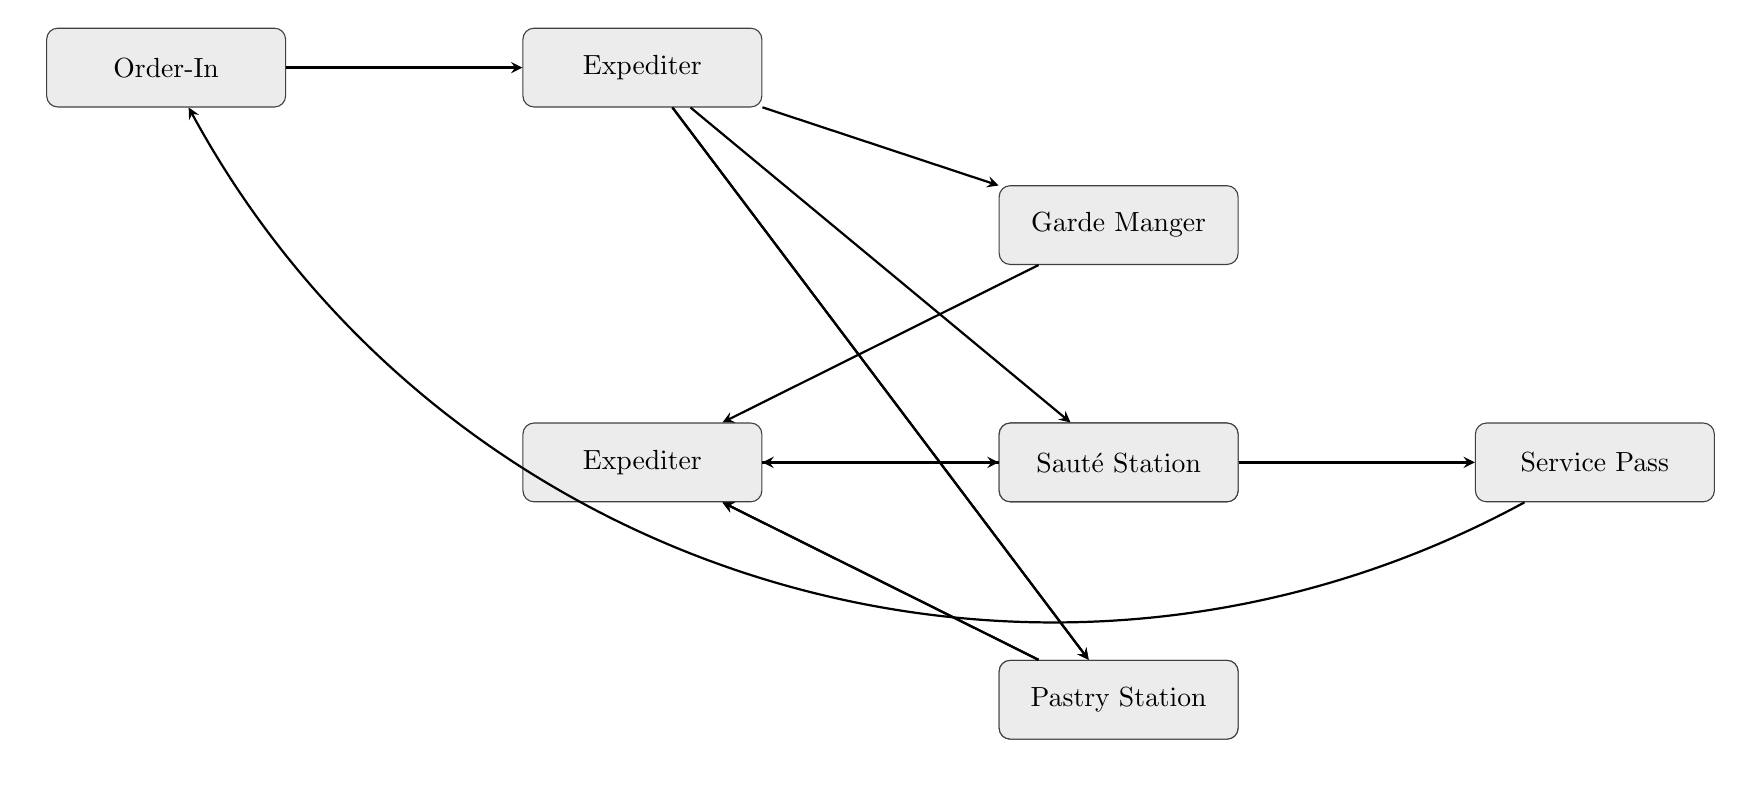What's the first node in the flow? The flow starts with the "Order-In" node where customer orders are received and entered into the system. This is the first step in the communication flow.
Answer: Order-In How many stations communicate with the Expediter? There are four stations that communicate with the Expediter: Garde Manger, Sauté Station, Grill Station, and Pastry Station. This can be counted directly from the arrows leading to the Expediter node.
Answer: Four What does the Garde Manger station prepare? The Garde Manger station prepares cold dishes like salads and appetizers, which is its primary responsibility outlined in the diagram's description of the node.
Answer: Cold dishes Which node follows the Plating node? After the Plating node, the next node is the Service Pass. This is depicted with an arrow leading from Plating to Service Pass in the diagram.
Answer: Service Pass What is the final step before orders are handed to the waitstaff? The final step before handing orders to the waitstaff is the Service Pass node, where a final quality check and handoff occur. This is the last node in the flow before returning to Order-In.
Answer: Service Pass Which node is responsible for coordinating doneness with the Expediter? The Grill Station is responsible for coordinating doneness with the Expediter, as noted in its function described in the diagram.
Answer: Grill Station If the Garde Manger finishes an order, where does it communicate next? If the Garde Manger finishes an order, it communicates back to the Expediter. This is indicated by the arrow that connects Garde Manger to the Expediter node in the flow chart.
Answer: Expediter What overall role does the Expediter play in this flow? The Expediter plays a crucial role in reviewing and prioritizing orders, communicating with stations, and performing a final check of dish readiness before plating. This is summarized in the description associated with the Expediter node.
Answer: Coordination How are ready dishes verified before plating? Ready dishes are verified by the Plating team in the Plating node, which confirms readiness with the Expediter before final assembly and presentation. This relationship is indicated by the arrow from Expediter to Plating.
Answer: By the Plating team 